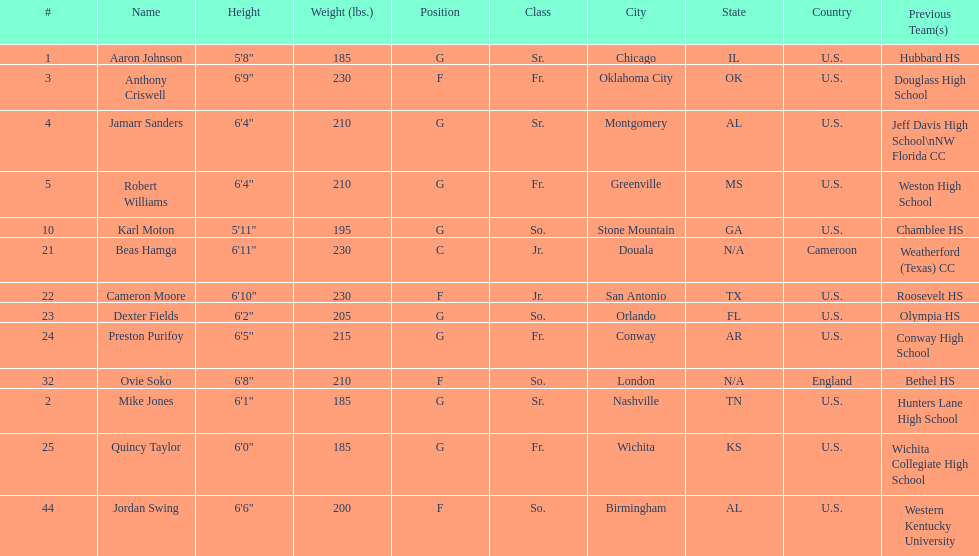Tell me the number of juniors on the team. 2. 